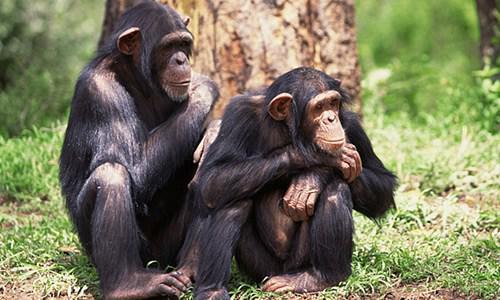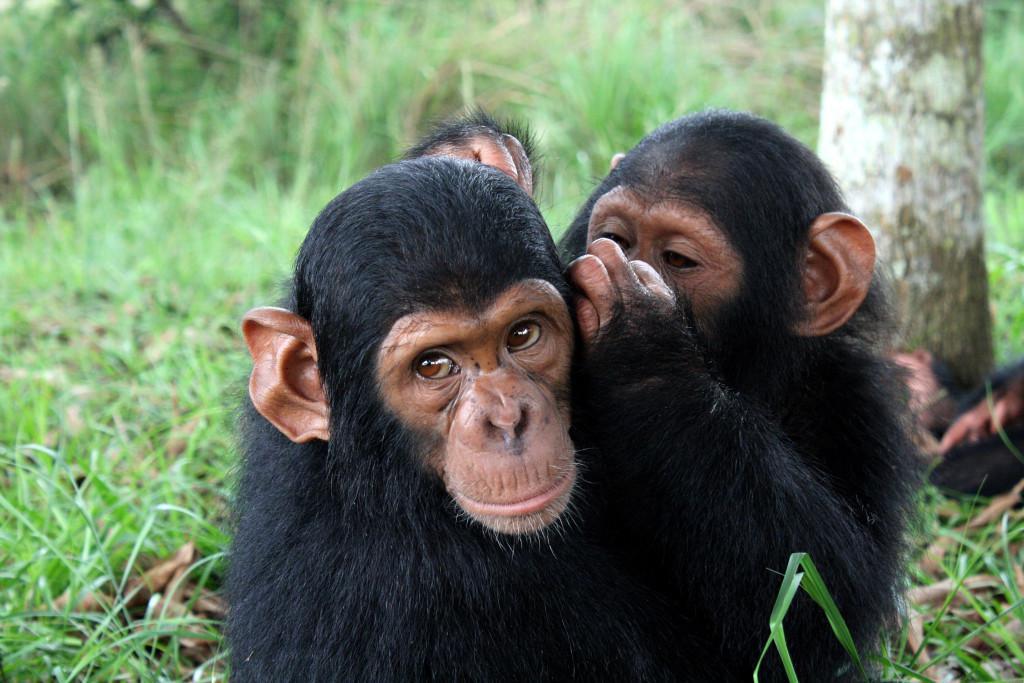The first image is the image on the left, the second image is the image on the right. For the images displayed, is the sentence "There are at least two chimpanzees in each image." factually correct? Answer yes or no. Yes. The first image is the image on the left, the second image is the image on the right. Analyze the images presented: Is the assertion "There is more than one chimp in every single image." valid? Answer yes or no. Yes. 